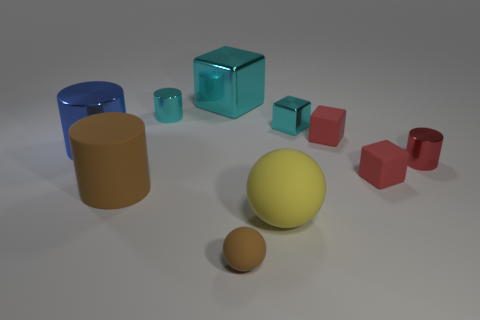What shape is the tiny red thing that is the same material as the tiny cyan cylinder?
Offer a terse response. Cylinder. There is a tiny metallic object in front of the large blue thing; is its shape the same as the tiny brown object?
Give a very brief answer. No. There is a large object in front of the large brown object; what shape is it?
Give a very brief answer. Sphere. What is the shape of the small object that is the same color as the small shiny cube?
Give a very brief answer. Cylinder. What number of blue cylinders are the same size as the red cylinder?
Ensure brevity in your answer.  0. What color is the big rubber cylinder?
Offer a very short reply. Brown. There is a big rubber sphere; does it have the same color as the big rubber thing left of the large cyan metallic block?
Your response must be concise. No. There is a brown cylinder that is the same material as the big yellow sphere; what size is it?
Offer a very short reply. Large. Is there a rubber cylinder of the same color as the tiny metal block?
Provide a short and direct response. No. How many objects are either small cylinders that are on the right side of the large cyan cube or small red metal cylinders?
Offer a terse response. 1. 